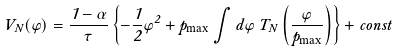<formula> <loc_0><loc_0><loc_500><loc_500>V _ { N } ( \varphi ) = \frac { 1 - \alpha } { \tau } \left \{ - \frac { 1 } { 2 } \varphi ^ { 2 } + p _ { \max } \int d \varphi \, T _ { N } \left ( \frac { \varphi } { p _ { \max } } \right ) \right \} + c o n s t</formula> 